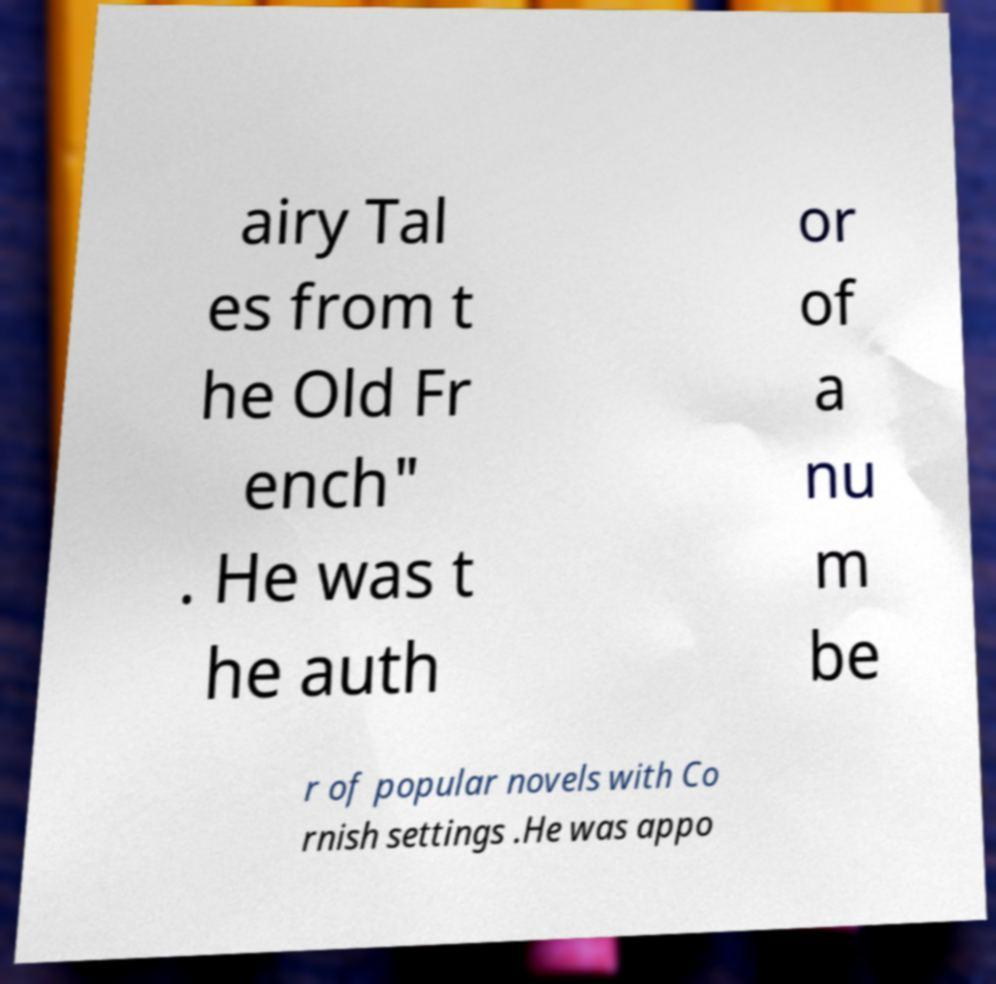Can you accurately transcribe the text from the provided image for me? airy Tal es from t he Old Fr ench" . He was t he auth or of a nu m be r of popular novels with Co rnish settings .He was appo 